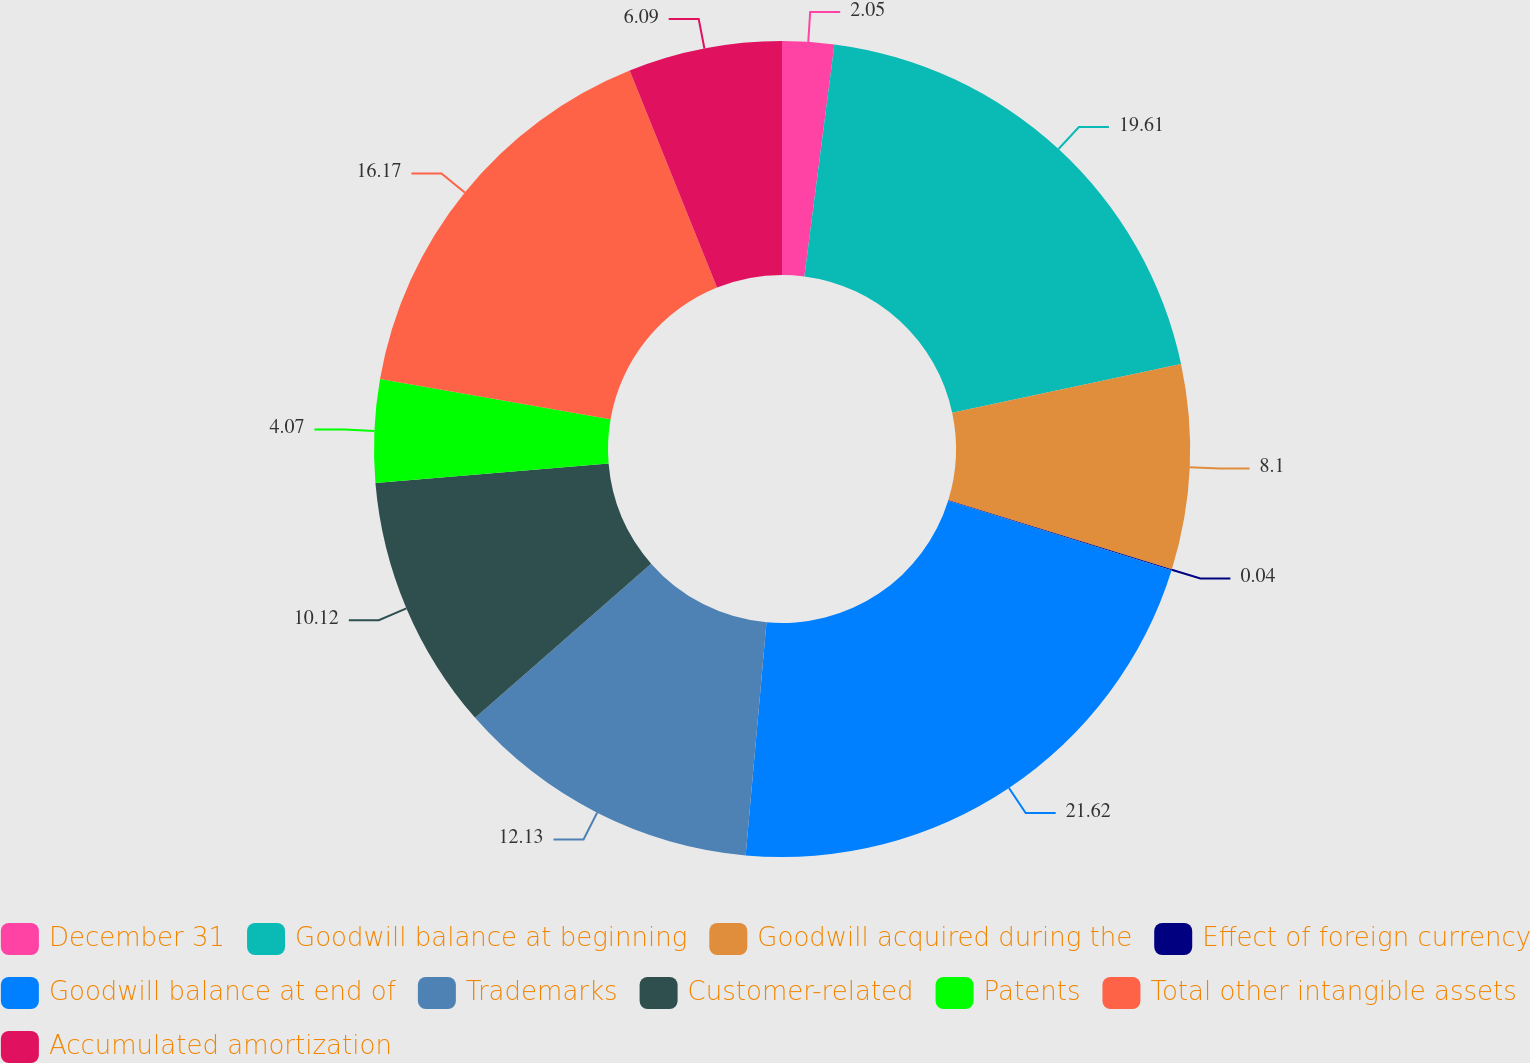Convert chart. <chart><loc_0><loc_0><loc_500><loc_500><pie_chart><fcel>December 31<fcel>Goodwill balance at beginning<fcel>Goodwill acquired during the<fcel>Effect of foreign currency<fcel>Goodwill balance at end of<fcel>Trademarks<fcel>Customer-related<fcel>Patents<fcel>Total other intangible assets<fcel>Accumulated amortization<nl><fcel>2.05%<fcel>19.61%<fcel>8.1%<fcel>0.04%<fcel>21.62%<fcel>12.13%<fcel>10.12%<fcel>4.07%<fcel>16.17%<fcel>6.09%<nl></chart> 